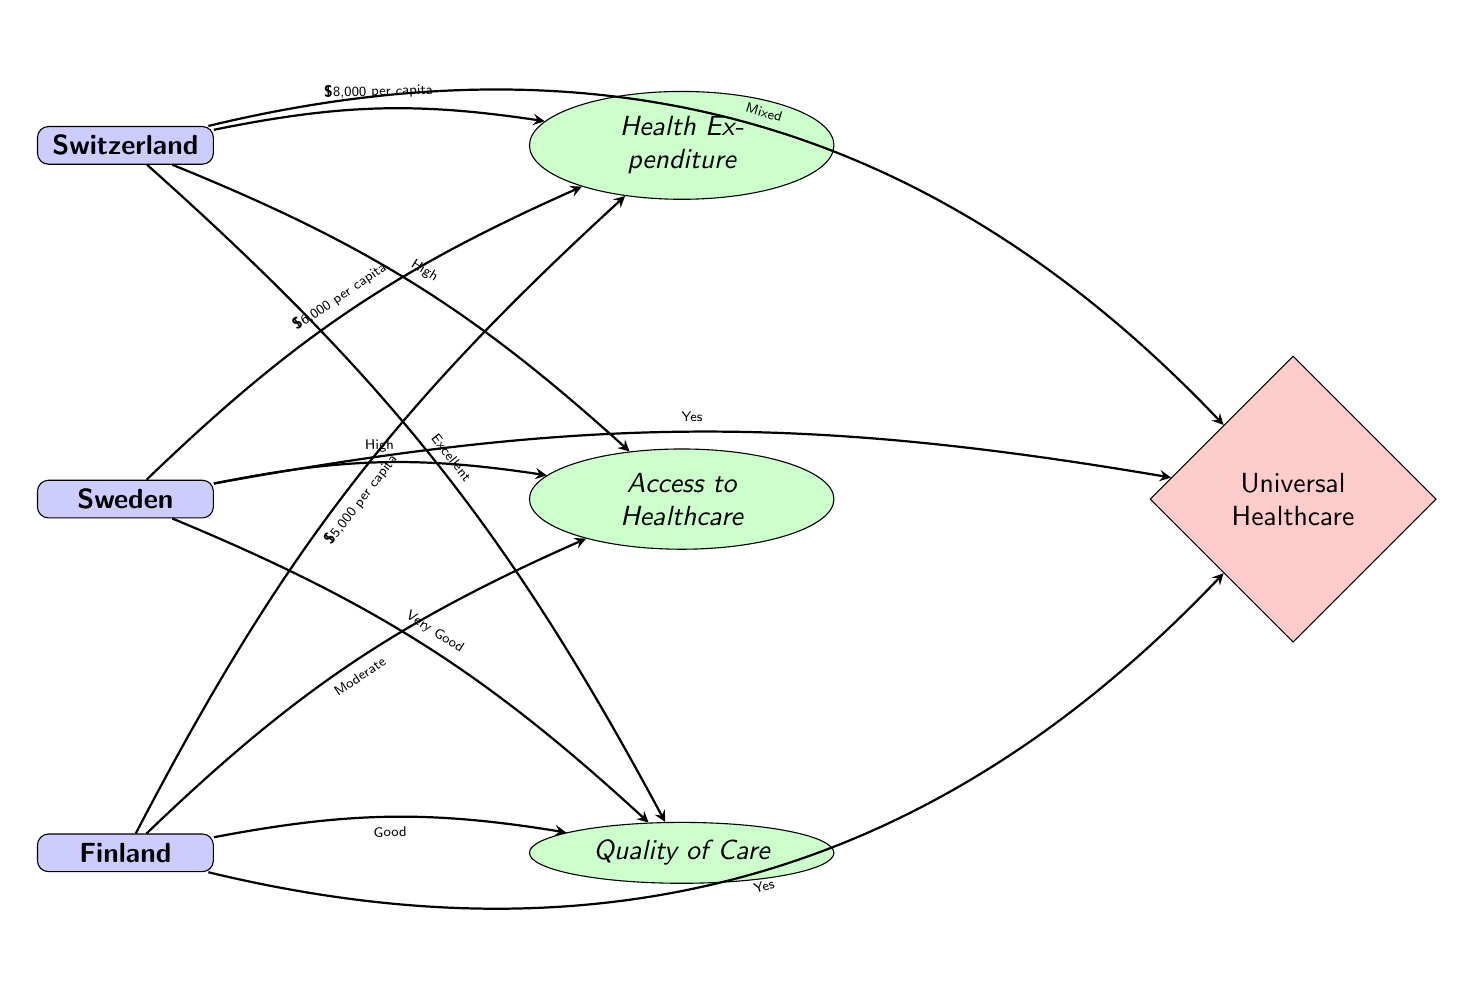What is the health expenditure per capita for Switzerland? The diagram specifies the health expenditure for Switzerland in the edge connecting the country node to the metric node labeled "Health Expenditure." The label on the edge indicates it is \$8,000 per capita.
Answer: \$8,000 per capita What is the quality of care rating for Finland? To determine the quality of care for Finland, we look at the connecting edge to the metric labeled "Quality of Care." The edge specifies that the quality of care rating for Finland is "Good."
Answer: Good How many countries are represented in the diagram? The diagram has three country nodes: Switzerland, Sweden, and Finland. Therefore, the count of country nodes is 3.
Answer: 3 What is the access to healthcare level in Sweden? The diagram shows the access to healthcare level for Sweden in the edge leading to the metric node labeled "Access to Healthcare." The edge states that Sweden has a "High" access level.
Answer: High Which country has the lowest health expenditure per capita? Among the health expenditures listed, Switzerland has \$8,000, Sweden has \$6,000, and Finland has \$5,000. The lowest expenditure is associated with Finland.
Answer: \$5,000 per capita What type of healthcare policy is implemented in Switzerland? The edge connecting Switzerland to the policy node labeled "Universal Healthcare" states that the healthcare policy in Switzerland is "Mixed."
Answer: Mixed Which country has the highest quality of care rating? The diagram indicates the quality of care ratings for each country: Switzerland has "Excellent," Sweden has "Very Good," and Finland has "Good." Therefore, Switzerland has the highest rating.
Answer: Excellent Do both Sweden and Finland have universal healthcare? The edges leading to the policy node labeled "Universal Healthcare" indicate that both Sweden and Finland have implemented universal healthcare, with Sweden marked as "Yes" and Finland also marked as "Yes."
Answer: Yes What type of healthcare policy does Sweden have? By reviewing the edge leading from Sweden to the policy node labeled "Universal Healthcare," it is shown that Sweden's healthcare policy is "Yes." This indicates that Sweden implements universal healthcare.
Answer: Yes 